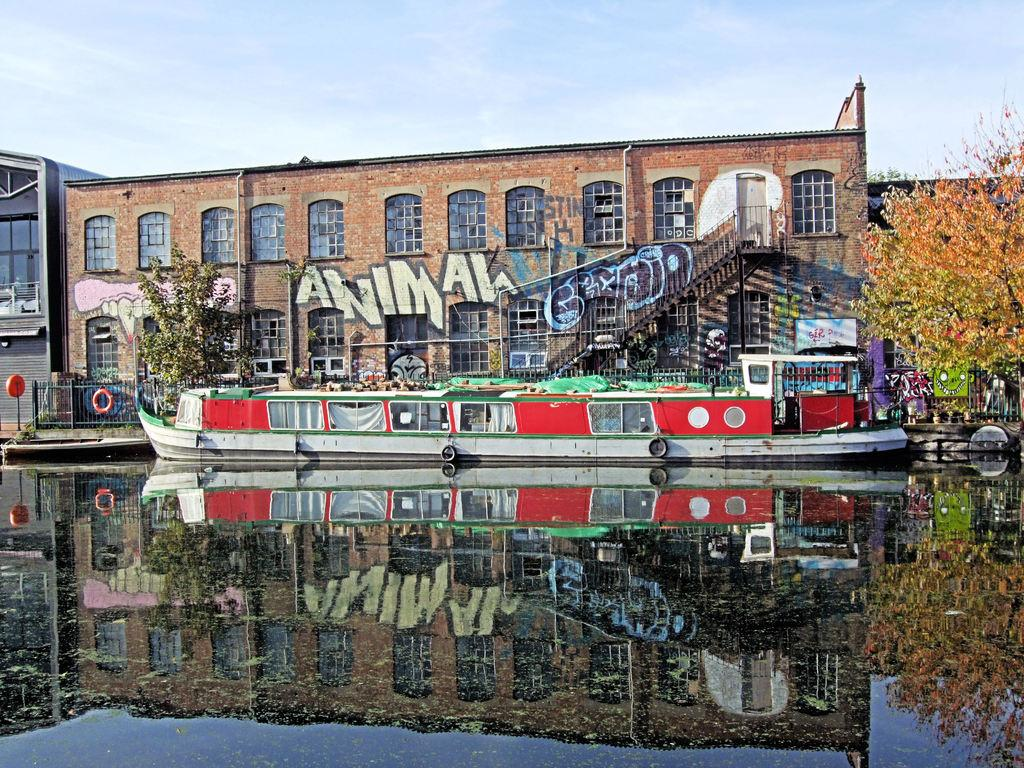What is the main subject of the image? The main subject of the image is a boat on water. What can be seen in the background of the image? The sky is visible in the background of the image. What type of structures are present in the image? There are buildings with windows in the image. What objects are related to water activities in the image? Swim tubes are present in the image. What additional objects can be seen in the image? There are other objects in the image, such as a fence and banners. How many basketballs are visible in the image? There are no basketballs present in the image. Is there a glove being used by someone in the image? There is no glove visible in the image. 